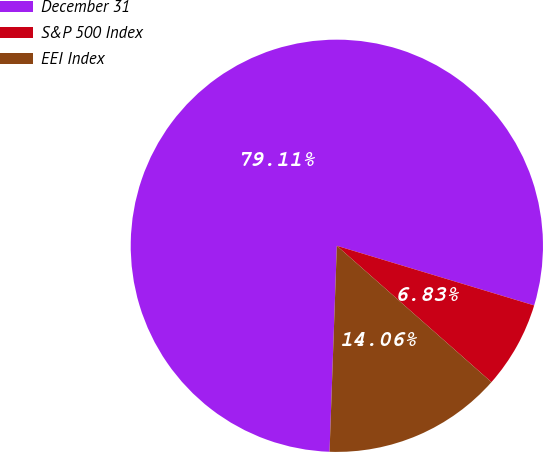<chart> <loc_0><loc_0><loc_500><loc_500><pie_chart><fcel>December 31<fcel>S&P 500 Index<fcel>EEI Index<nl><fcel>79.1%<fcel>6.83%<fcel>14.06%<nl></chart> 